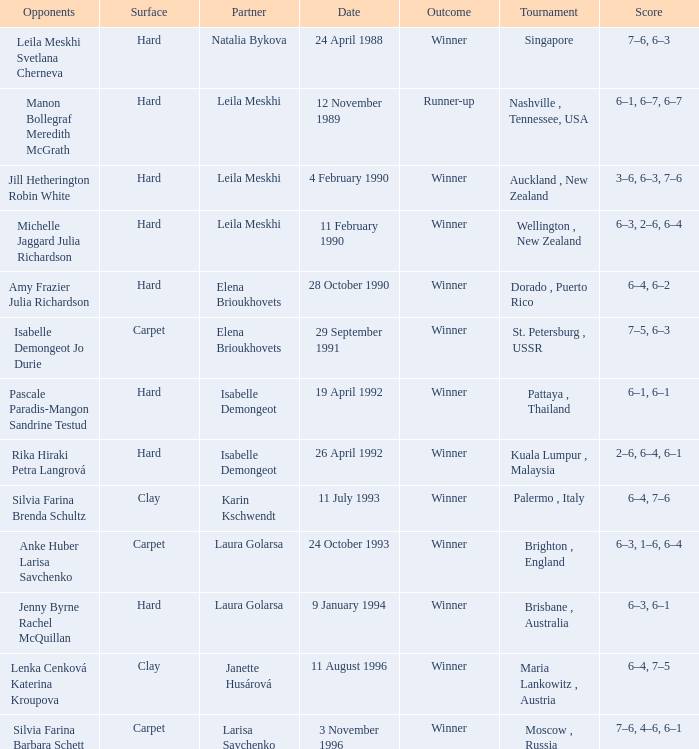In what Tournament was the Score of 3–6, 6–3, 7–6 in a match played on a hard Surface? Auckland , New Zealand. 